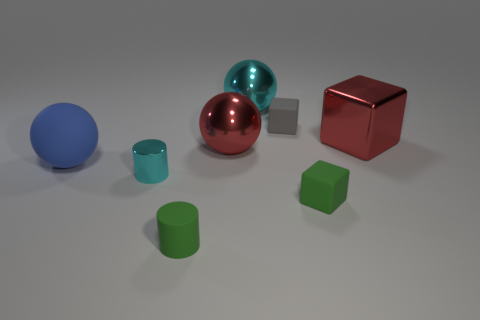Subtract all red cubes. How many cubes are left? 2 Subtract all gray cubes. How many cubes are left? 2 Subtract all spheres. How many objects are left? 5 Subtract 1 cylinders. How many cylinders are left? 1 Subtract 0 brown cylinders. How many objects are left? 8 Subtract all red cubes. Subtract all blue cylinders. How many cubes are left? 2 Subtract all red cylinders. How many gray blocks are left? 1 Subtract all cylinders. Subtract all gray blocks. How many objects are left? 5 Add 5 small metal objects. How many small metal objects are left? 6 Add 6 green shiny cylinders. How many green shiny cylinders exist? 6 